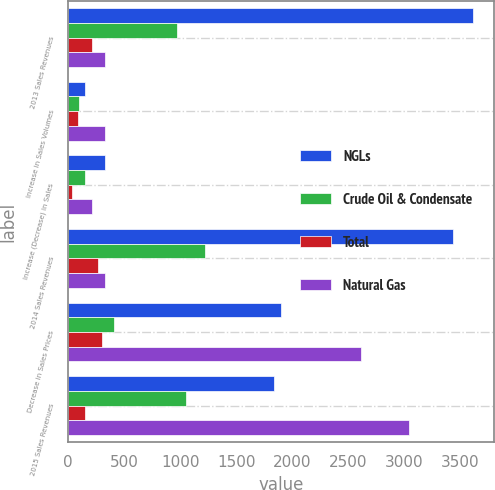Convert chart. <chart><loc_0><loc_0><loc_500><loc_500><stacked_bar_chart><ecel><fcel>2013 Sales Revenues<fcel>Increase in Sales Volumes<fcel>Increase (Decrease) in Sales<fcel>2014 Sales Revenues<fcel>Decrease in Sales Prices<fcel>2015 Sales Revenues<nl><fcel>NGLs<fcel>3618<fcel>147<fcel>327<fcel>3438<fcel>1904<fcel>1840<nl><fcel>Crude Oil & Condensate<fcel>976<fcel>99<fcel>148<fcel>1223<fcel>408<fcel>1056<nl><fcel>Total<fcel>215<fcel>85<fcel>30<fcel>270<fcel>304<fcel>147<nl><fcel>Natural Gas<fcel>329<fcel>331<fcel>209<fcel>329<fcel>2616<fcel>3043<nl></chart> 